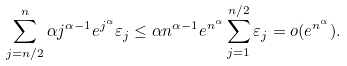Convert formula to latex. <formula><loc_0><loc_0><loc_500><loc_500>\sum _ { j = n / 2 } ^ { n } \alpha j ^ { \alpha - 1 } e ^ { j ^ { \alpha } } \varepsilon _ { j } \leq \alpha n ^ { \alpha - 1 } e ^ { n ^ { \alpha } } \sum _ { j = 1 } ^ { n / 2 } \varepsilon _ { j } = o ( e ^ { n ^ { \alpha } } ) .</formula> 